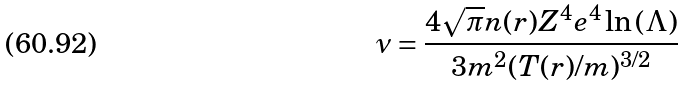Convert formula to latex. <formula><loc_0><loc_0><loc_500><loc_500>\nu = \frac { 4 \sqrt { \pi } n ( { r } ) Z ^ { 4 } e ^ { 4 } \ln { ( \Lambda ) } } { 3 m ^ { 2 } ( T ( { r } ) / m ) ^ { 3 / 2 } }</formula> 